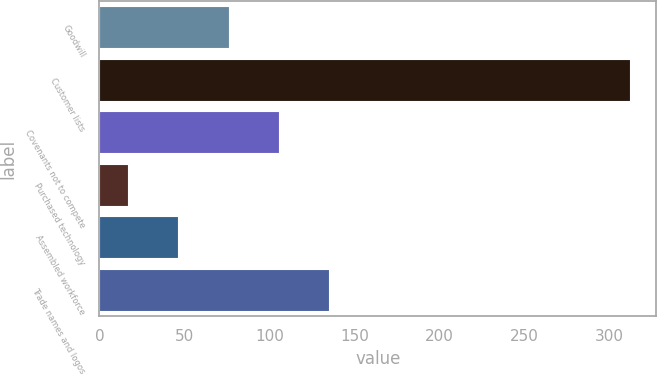<chart> <loc_0><loc_0><loc_500><loc_500><bar_chart><fcel>Goodwill<fcel>Customer lists<fcel>Covenants not to compete<fcel>Purchased technology<fcel>Assembled workforce<fcel>Trade names and logos<nl><fcel>76<fcel>312<fcel>105.5<fcel>17<fcel>46.5<fcel>135<nl></chart> 